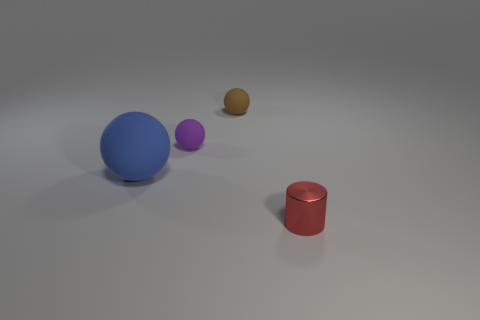Is there anything else that has the same material as the small cylinder?
Provide a short and direct response. No. Are there any small brown spheres made of the same material as the purple thing?
Make the answer very short. Yes. How many red things are either tiny matte objects or cylinders?
Make the answer very short. 1. Are there any rubber balls of the same color as the small metal thing?
Your answer should be compact. No. The brown ball that is the same material as the purple sphere is what size?
Your answer should be very brief. Small. How many cubes are small rubber things or big rubber objects?
Your response must be concise. 0. Is the number of small metal objects greater than the number of small yellow metal cubes?
Offer a very short reply. Yes. What number of red metallic cylinders are the same size as the purple thing?
Make the answer very short. 1. How many things are tiny matte objects that are behind the purple thing or big yellow cubes?
Your answer should be compact. 1. Are there fewer rubber things than big things?
Provide a short and direct response. No. 